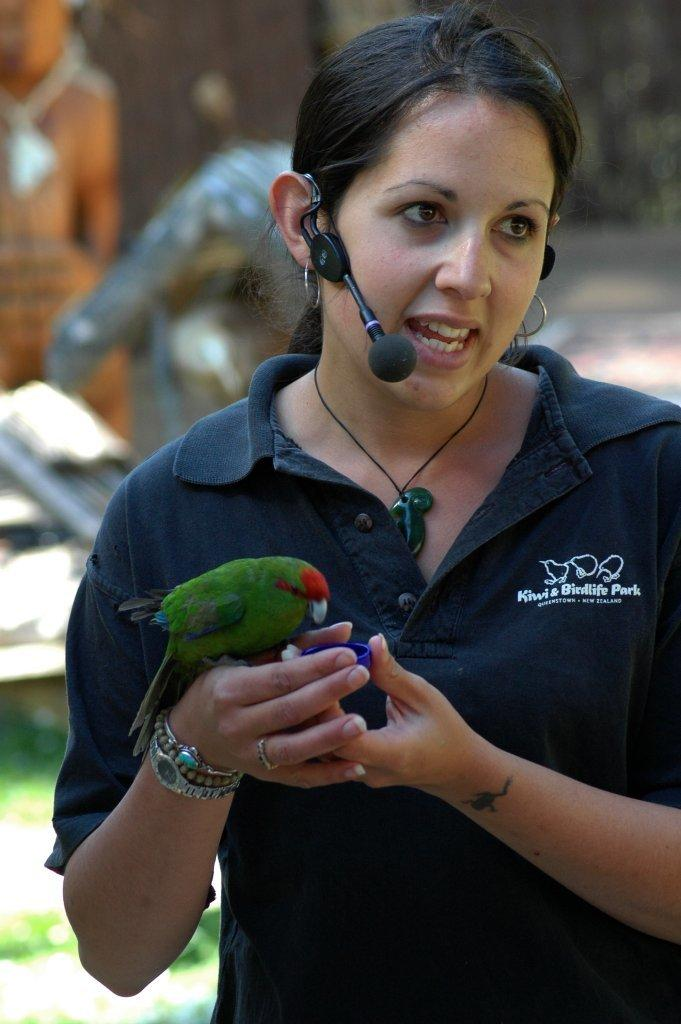Who is the main subject in the image? There is a woman in the image. What is the woman wearing? The woman is wearing a microphone. What is the woman holding in the image? The woman is holding a parrot. Can you describe the background of the image? There might be a person in the background on the left side of the image. What type of tin can be seen in the woman's pocket in the image? There is no tin visible in the image, nor is there any mention of a pocket. 